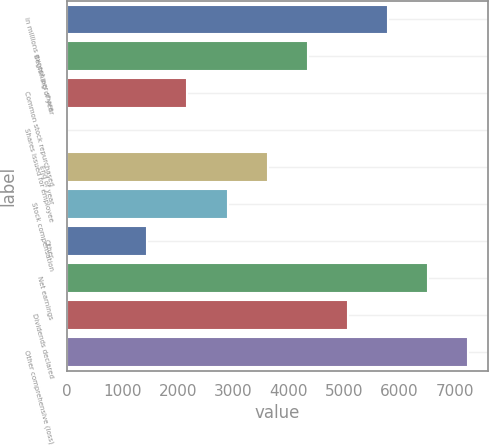<chart> <loc_0><loc_0><loc_500><loc_500><bar_chart><fcel>in millions except per share<fcel>Beginning of year<fcel>Common stock repurchased<fcel>Shares issued for employee<fcel>End of year<fcel>Stock compensation<fcel>Other<fcel>Net earnings<fcel>Dividends declared<fcel>Other comprehensive (loss)<nl><fcel>5788.4<fcel>4341.8<fcel>2171.9<fcel>2<fcel>3618.5<fcel>2895.2<fcel>1448.6<fcel>6511.7<fcel>5065.1<fcel>7235<nl></chart> 